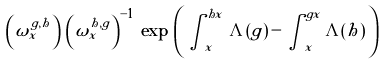Convert formula to latex. <formula><loc_0><loc_0><loc_500><loc_500>\left ( \omega ^ { g , h } _ { x } \right ) \, \left ( \omega ^ { h , g } _ { x } \right ) ^ { - 1 } \, \exp \, \left ( \, \int ^ { h x } _ { x } \, \Lambda ( g ) \, - \, \int ^ { g x } _ { x } \Lambda ( h ) \, \right )</formula> 